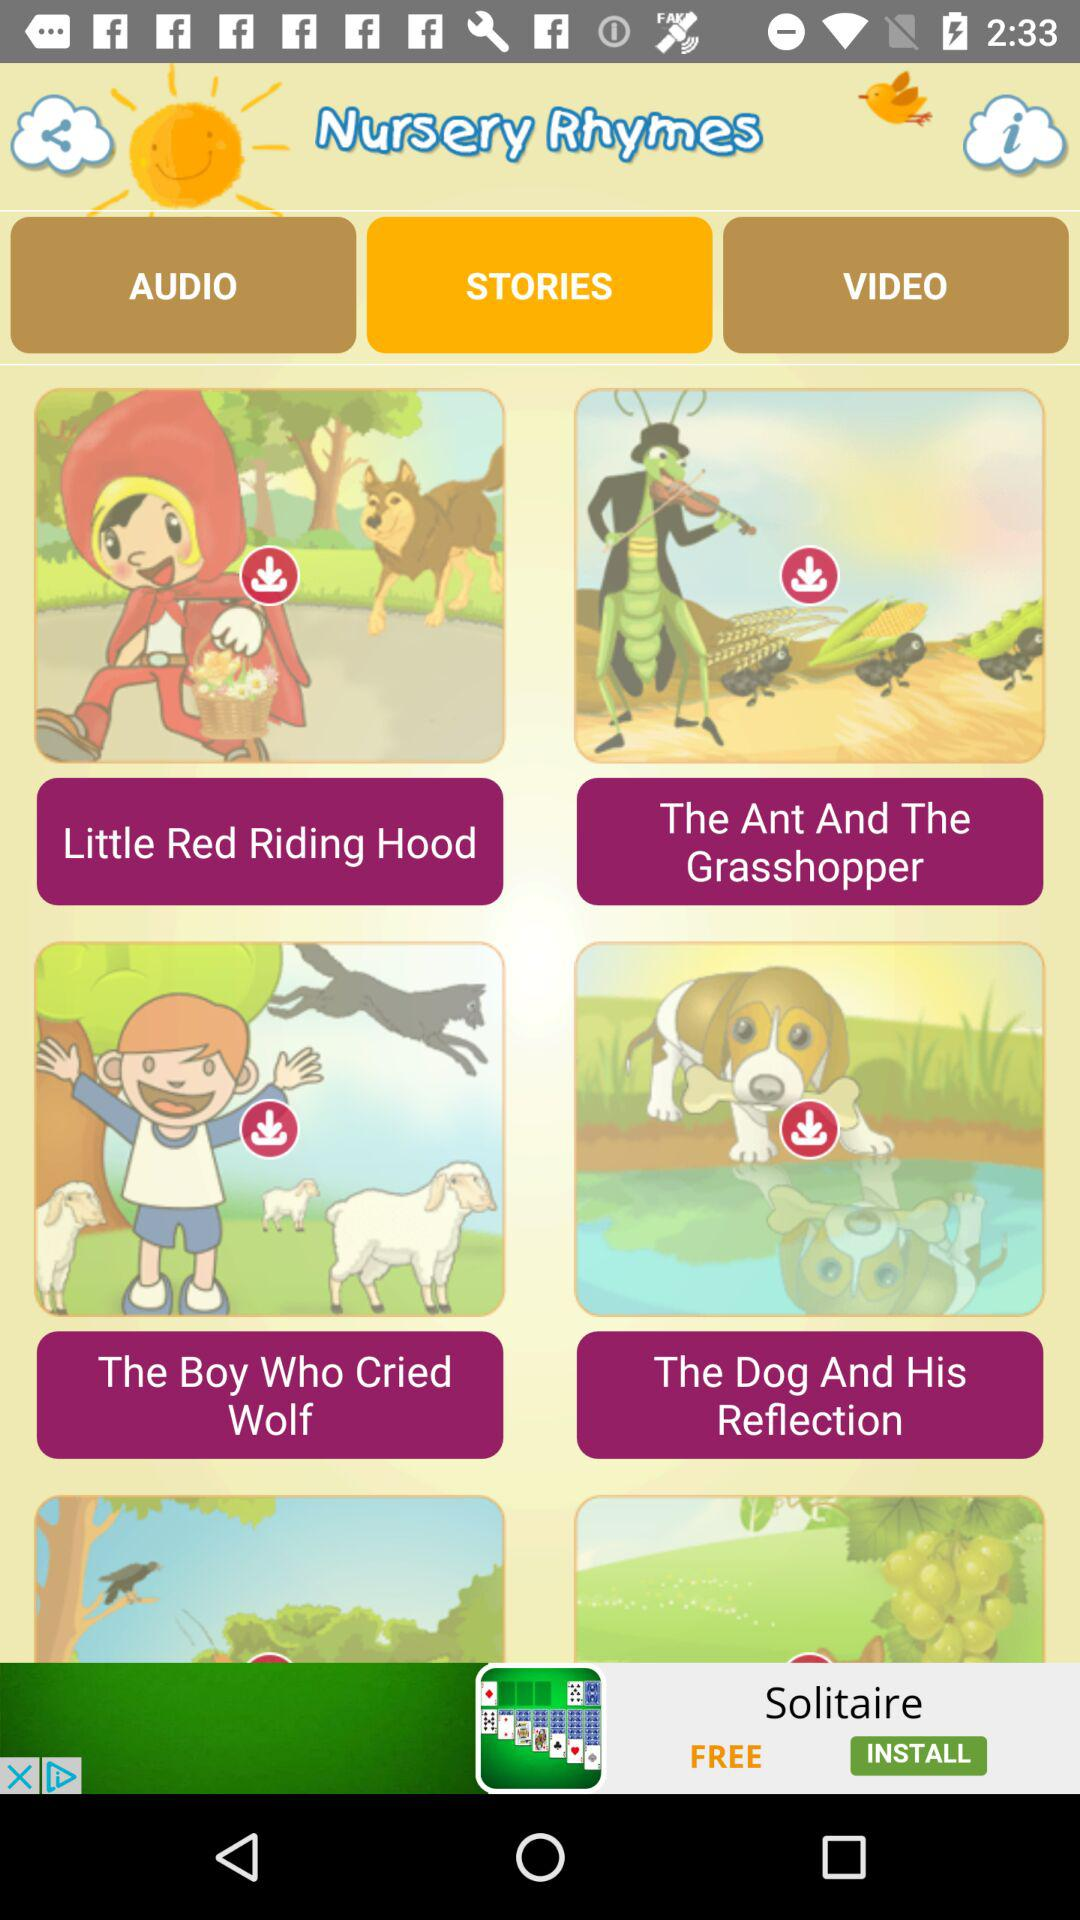Which are the different stories? The different stories are "Little Red Riding Hood", "The Ant And The Grasshopper", "The Boy Who Cried Wolf" and "The Dog And His Reflection". 